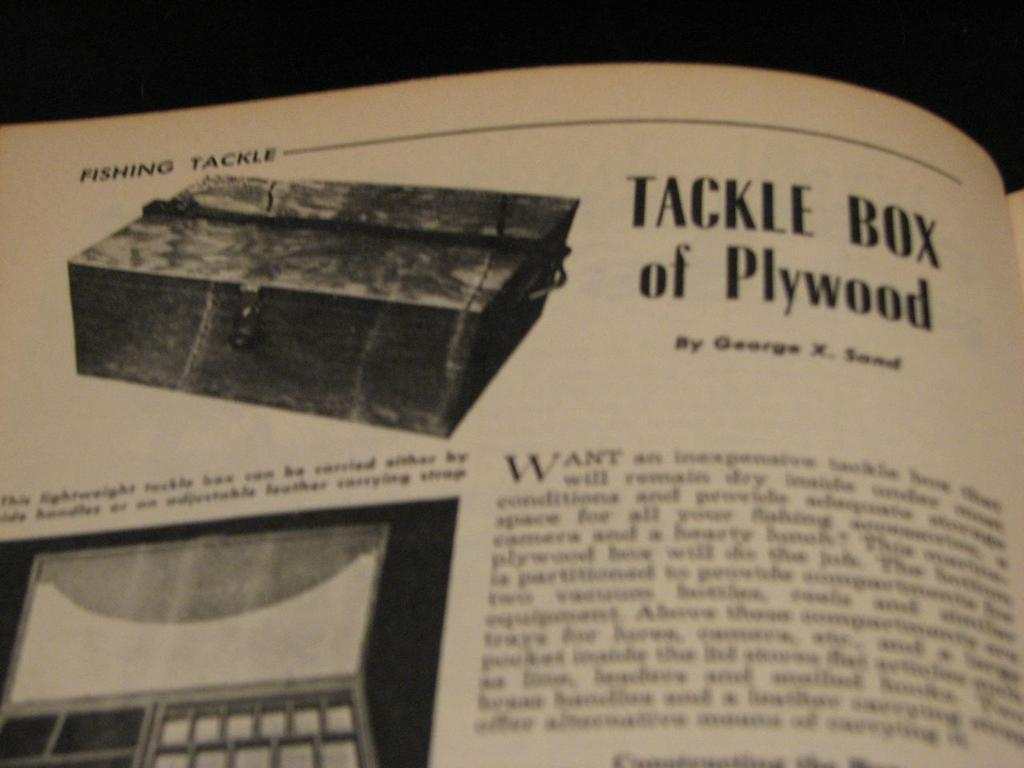Provide a one-sentence caption for the provided image. A magazine featuring a photo of a tackle box of plywood. 